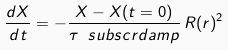Convert formula to latex. <formula><loc_0><loc_0><loc_500><loc_500>\frac { d X } { d t } = - \frac { X - X ( t = 0 ) } { \tau \ s u b s c r { d a m p } } \, R ( r ) ^ { 2 }</formula> 